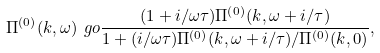Convert formula to latex. <formula><loc_0><loc_0><loc_500><loc_500>\Pi ^ { ( 0 ) } ( k , \omega ) \ g o \frac { ( 1 + i / \omega \tau ) \Pi ^ { ( 0 ) } ( k , \omega + i / \tau ) } { 1 + ( i / \omega \tau ) \Pi ^ { ( 0 ) } ( k , \omega + i / \tau ) / \Pi ^ { ( 0 ) } ( k , 0 ) } ,</formula> 